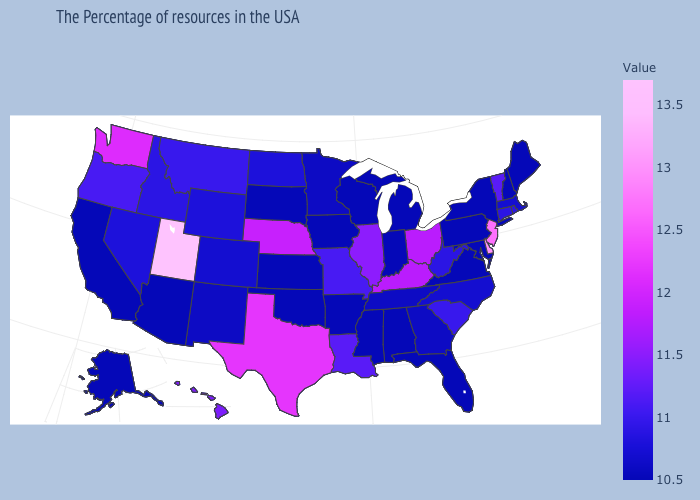Among the states that border Vermont , which have the highest value?
Answer briefly. Massachusetts. Does the map have missing data?
Concise answer only. No. Does Utah have the highest value in the USA?
Answer briefly. Yes. Among the states that border Georgia , does South Carolina have the highest value?
Concise answer only. Yes. Does the map have missing data?
Concise answer only. No. Does Utah have the highest value in the USA?
Concise answer only. Yes. Among the states that border Connecticut , which have the lowest value?
Short answer required. New York. Which states have the lowest value in the USA?
Answer briefly. Maine, New Hampshire, New York, Maryland, Pennsylvania, Virginia, Florida, Michigan, Indiana, Alabama, Wisconsin, Mississippi, Arkansas, Iowa, Kansas, Oklahoma, South Dakota, Arizona, California, Alaska. 